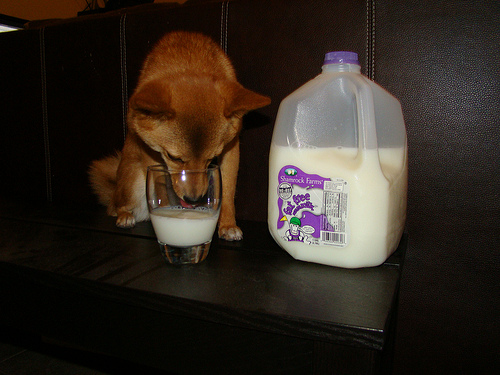<image>
Is the milk next to the glass? Yes. The milk is positioned adjacent to the glass, located nearby in the same general area. 